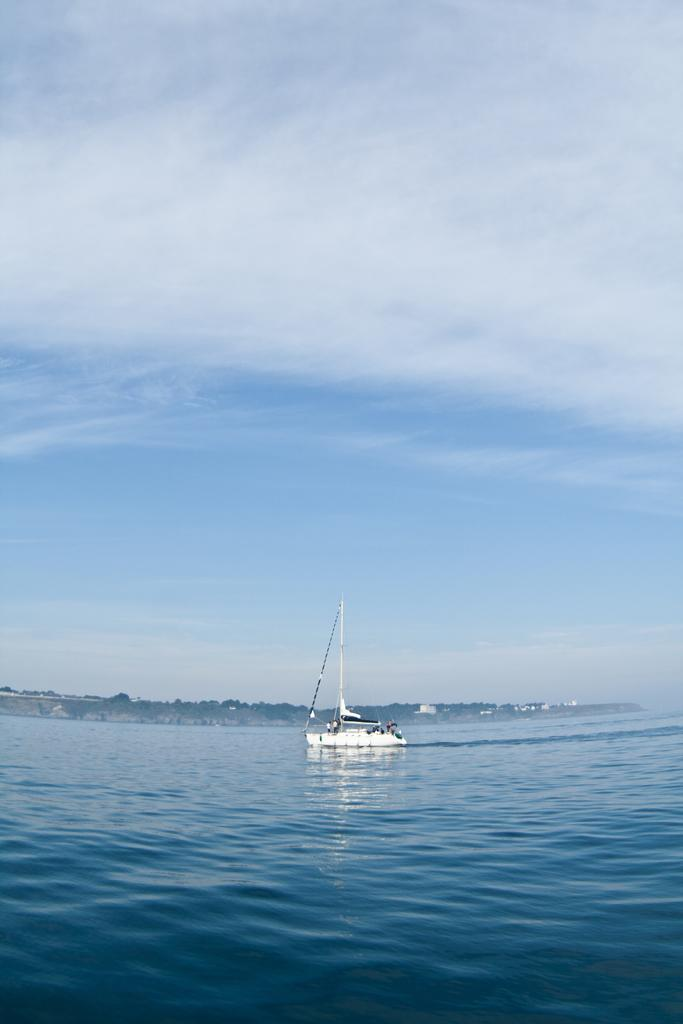What is the main subject of the image? The main subject of the image is a ship. Where is the ship located in the image? The ship is on the water in the image. What can be seen in the background of the image? There is sky visible in the background of the image. What type of snail can be seen crawling on the ship's deck in the image? There is no snail present on the ship's deck in the image. What color are the trousers worn by the captain of the ship in the image? There is no captain or trousers visible in the image; it only shows a ship on the water. 